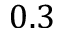<formula> <loc_0><loc_0><loc_500><loc_500>0 . 3</formula> 